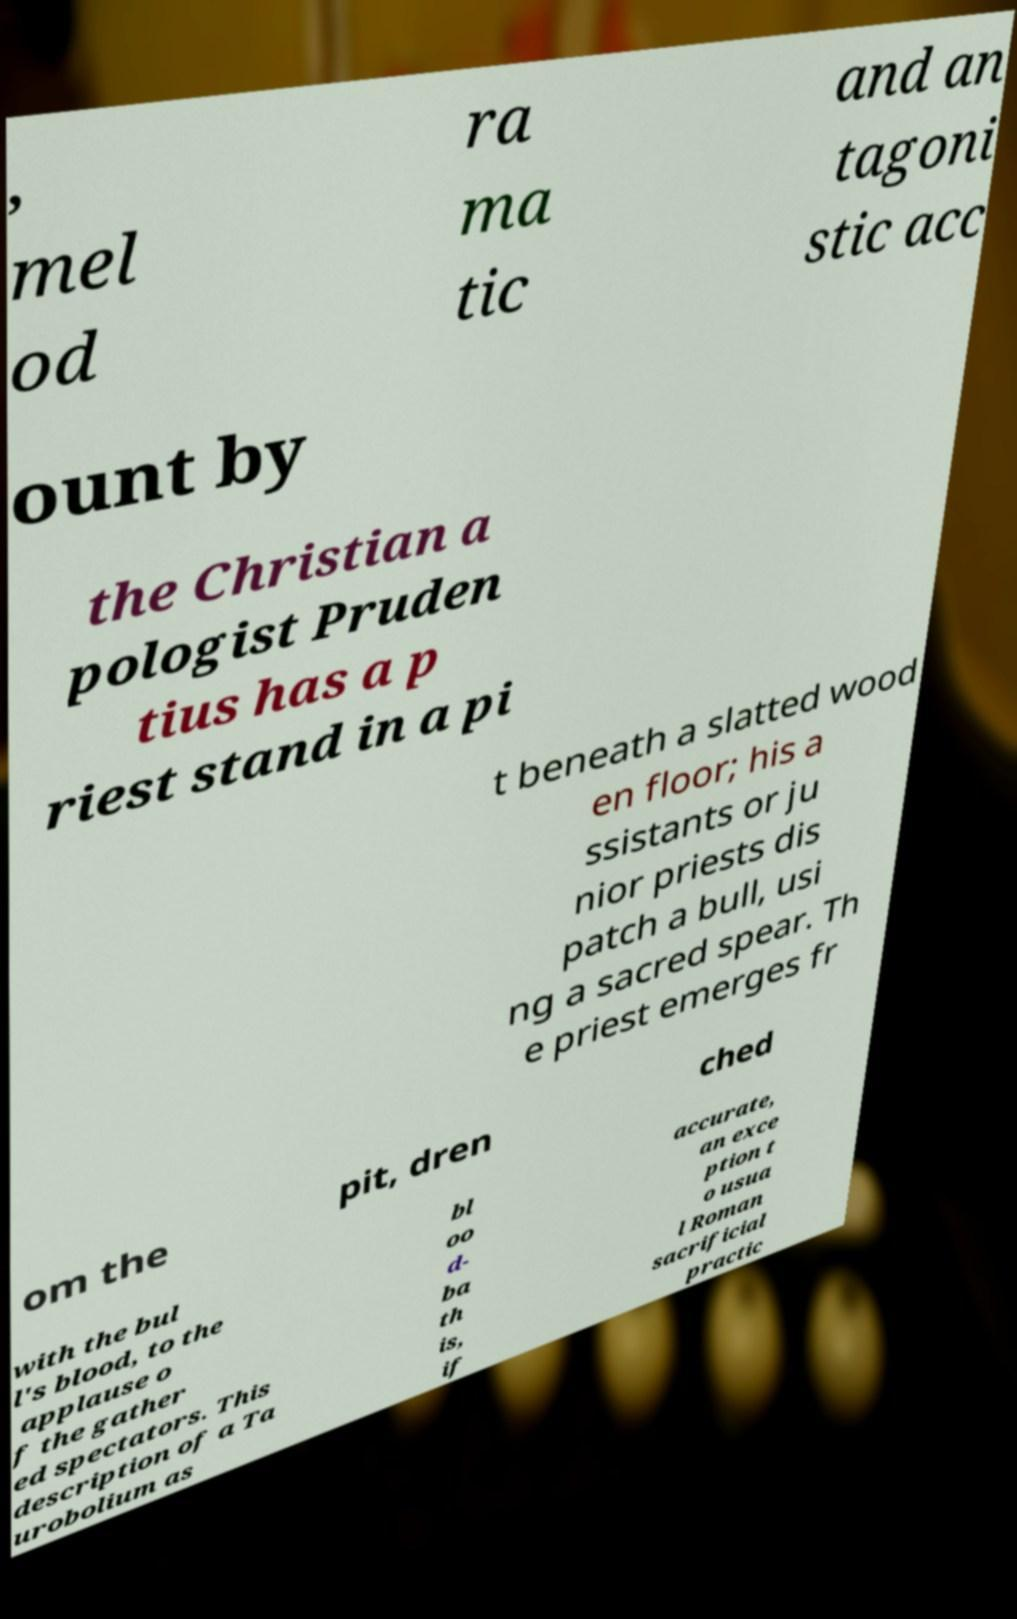Could you extract and type out the text from this image? , mel od ra ma tic and an tagoni stic acc ount by the Christian a pologist Pruden tius has a p riest stand in a pi t beneath a slatted wood en floor; his a ssistants or ju nior priests dis patch a bull, usi ng a sacred spear. Th e priest emerges fr om the pit, dren ched with the bul l's blood, to the applause o f the gather ed spectators. This description of a Ta urobolium as bl oo d- ba th is, if accurate, an exce ption t o usua l Roman sacrificial practic 